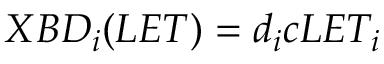Convert formula to latex. <formula><loc_0><loc_0><loc_500><loc_500>X B D _ { i } ( L E T ) = d _ { i } c L E T _ { i }</formula> 